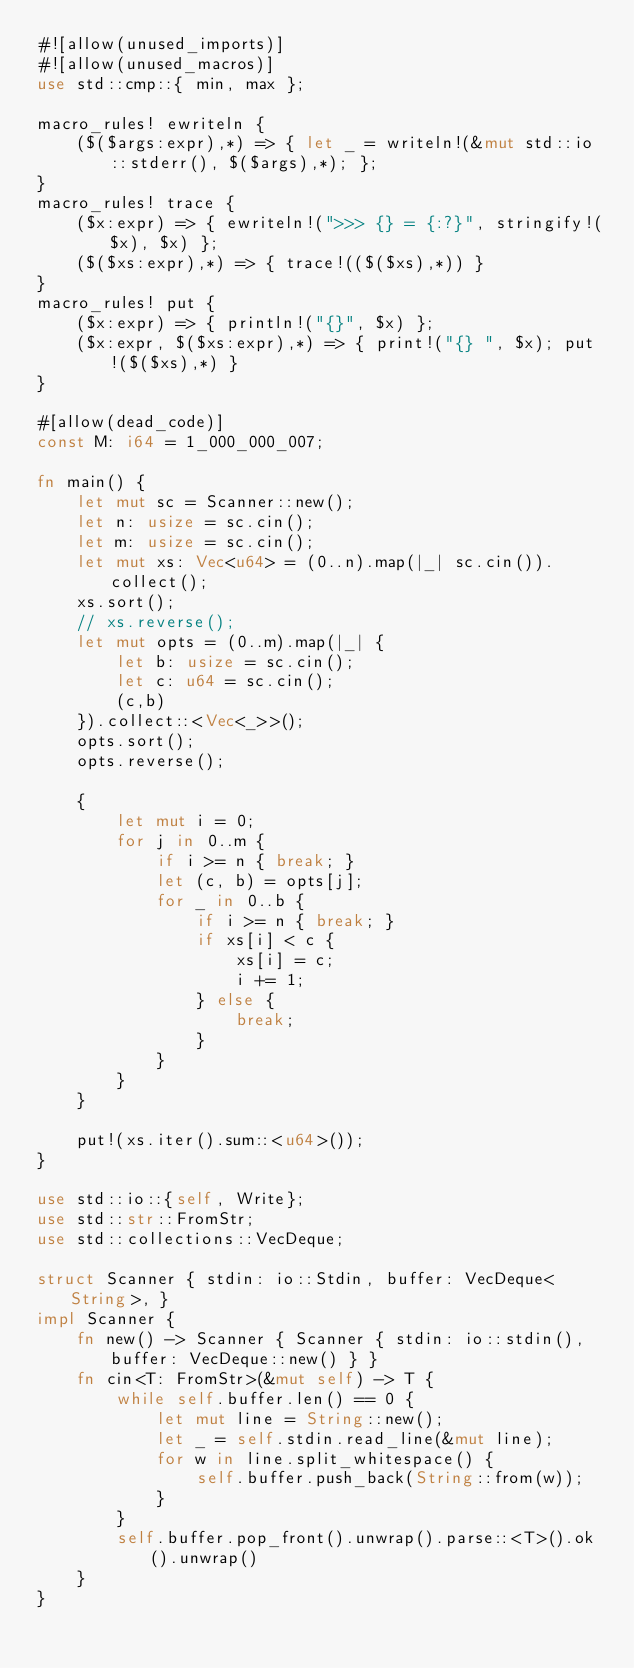Convert code to text. <code><loc_0><loc_0><loc_500><loc_500><_Rust_>#![allow(unused_imports)]
#![allow(unused_macros)]
use std::cmp::{ min, max };

macro_rules! ewriteln {
    ($($args:expr),*) => { let _ = writeln!(&mut std::io::stderr(), $($args),*); };
}
macro_rules! trace {
    ($x:expr) => { ewriteln!(">>> {} = {:?}", stringify!($x), $x) };
    ($($xs:expr),*) => { trace!(($($xs),*)) }
}
macro_rules! put {
    ($x:expr) => { println!("{}", $x) };
    ($x:expr, $($xs:expr),*) => { print!("{} ", $x); put!($($xs),*) }
}

#[allow(dead_code)]
const M: i64 = 1_000_000_007;

fn main() {
    let mut sc = Scanner::new();
    let n: usize = sc.cin();
    let m: usize = sc.cin();
    let mut xs: Vec<u64> = (0..n).map(|_| sc.cin()).collect();
    xs.sort();
    // xs.reverse();
    let mut opts = (0..m).map(|_| {
        let b: usize = sc.cin();
        let c: u64 = sc.cin();
        (c,b)
    }).collect::<Vec<_>>();
    opts.sort();
    opts.reverse();

    {
        let mut i = 0;
        for j in 0..m {
            if i >= n { break; }
            let (c, b) = opts[j];
            for _ in 0..b {
                if i >= n { break; }
                if xs[i] < c {
                    xs[i] = c;
                    i += 1;
                } else {
                    break;
                }
            }
        }
    }

    put!(xs.iter().sum::<u64>());
}

use std::io::{self, Write};
use std::str::FromStr;
use std::collections::VecDeque;

struct Scanner { stdin: io::Stdin, buffer: VecDeque<String>, }
impl Scanner {
    fn new() -> Scanner { Scanner { stdin: io::stdin(), buffer: VecDeque::new() } }
    fn cin<T: FromStr>(&mut self) -> T {
        while self.buffer.len() == 0 {
            let mut line = String::new();
            let _ = self.stdin.read_line(&mut line);
            for w in line.split_whitespace() {
                self.buffer.push_back(String::from(w));
            }
        }
        self.buffer.pop_front().unwrap().parse::<T>().ok().unwrap()
    }
}
</code> 